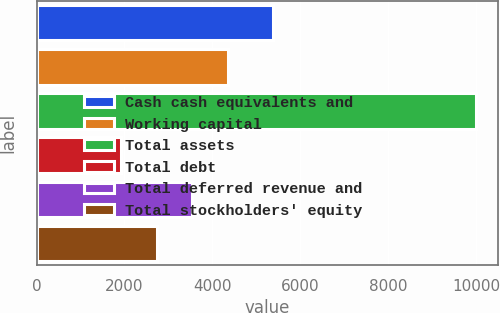Convert chart to OTSL. <chart><loc_0><loc_0><loc_500><loc_500><bar_chart><fcel>Cash cash equivalents and<fcel>Working capital<fcel>Total assets<fcel>Total debt<fcel>Total deferred revenue and<fcel>Total stockholders' equity<nl><fcel>5391<fcel>4345.5<fcel>9991<fcel>1926<fcel>3539<fcel>2732.5<nl></chart> 